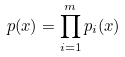Convert formula to latex. <formula><loc_0><loc_0><loc_500><loc_500>p ( x ) = \prod _ { i = 1 } ^ { m } p _ { i } ( x )</formula> 